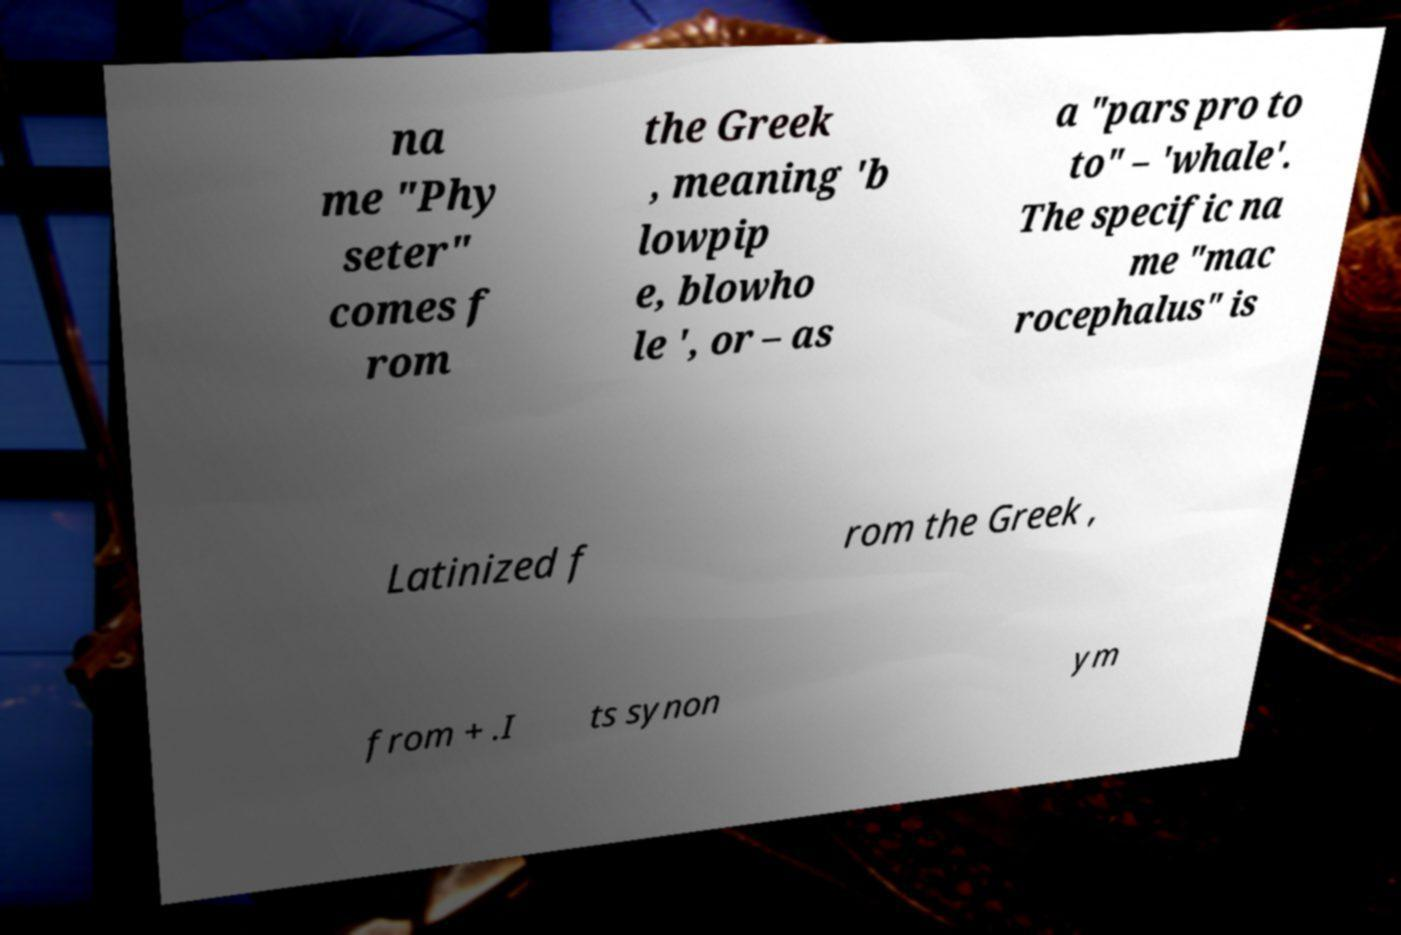Could you extract and type out the text from this image? na me "Phy seter" comes f rom the Greek , meaning 'b lowpip e, blowho le ', or – as a "pars pro to to" – 'whale'. The specific na me "mac rocephalus" is Latinized f rom the Greek , from + .I ts synon ym 